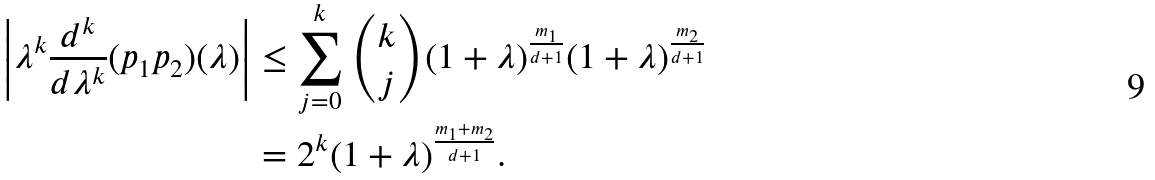<formula> <loc_0><loc_0><loc_500><loc_500>\left | \lambda ^ { k } \frac { d ^ { k } } { d \lambda ^ { k } } ( p _ { 1 } p _ { 2 } ) ( \lambda ) \right | & \leq \sum _ { j = 0 } ^ { k } \binom { k } { j } ( 1 + \lambda ) ^ { \frac { m _ { 1 } } { d + 1 } } ( 1 + \lambda ) ^ { \frac { m _ { 2 } } { d + 1 } } \\ & = 2 ^ { k } ( 1 + \lambda ) ^ { \frac { m _ { 1 } + m _ { 2 } } { d + 1 } } .</formula> 